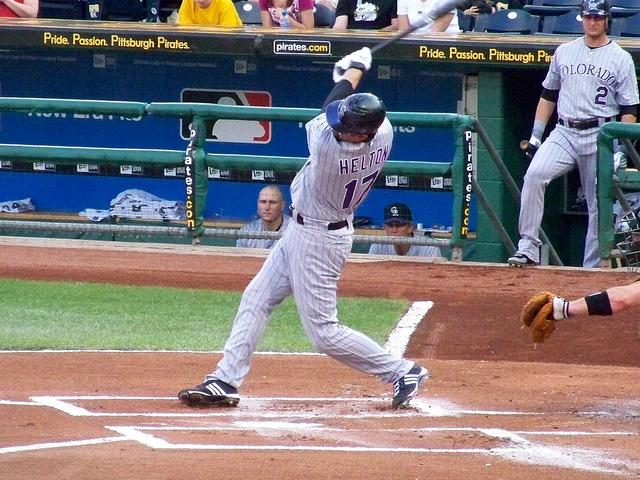Which city is the team in gray from?

Choices:
A) oakland
B) cleveland
C) colorado
D) cincinnati colorado 